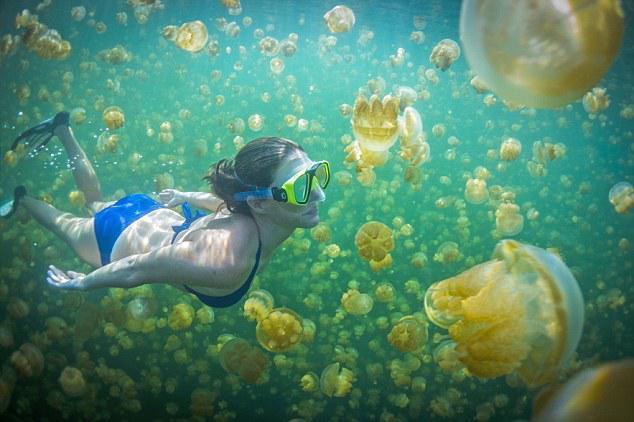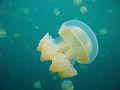The first image is the image on the left, the second image is the image on the right. Considering the images on both sides, is "There is a single large jellyfish in the image on the right." valid? Answer yes or no. Yes. 